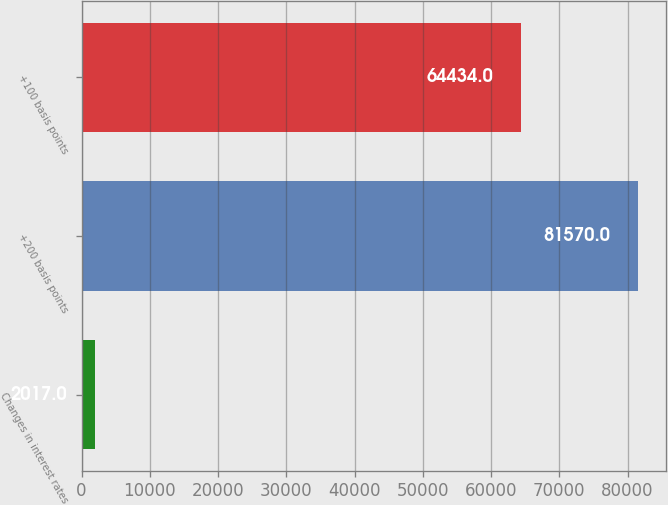<chart> <loc_0><loc_0><loc_500><loc_500><bar_chart><fcel>Changes in interest rates<fcel>+200 basis points<fcel>+100 basis points<nl><fcel>2017<fcel>81570<fcel>64434<nl></chart> 